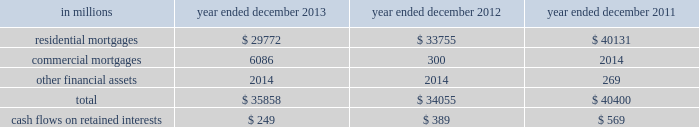Notes to consolidated financial statements note 10 .
Securitization activities the firm securitizes residential and commercial mortgages , corporate bonds , loans and other types of financial assets by selling these assets to securitization vehicles ( e.g. , trusts , corporate entities and limited liability companies ) or through a resecuritization .
The firm acts as underwriter of the beneficial interests that are sold to investors .
The firm 2019s residential mortgage securitizations are substantially all in connection with government agency securitizations .
Beneficial interests issued by securitization entities are debt or equity securities that give the investors rights to receive all or portions of specified cash inflows to a securitization vehicle and include senior and subordinated interests in principal , interest and/or other cash inflows .
The proceeds from the sale of beneficial interests are used to pay the transferor for the financial assets sold to the securitization vehicle or to purchase securities which serve as collateral .
The firm accounts for a securitization as a sale when it has relinquished control over the transferred assets .
Prior to securitization , the firm accounts for assets pending transfer at fair value and therefore does not typically recognize significant gains or losses upon the transfer of assets .
Net revenues from underwriting activities are recognized in connection with the sales of the underlying beneficial interests to investors .
For transfers of assets that are not accounted for as sales , the assets remain in 201cfinancial instruments owned , at fair value 201d and the transfer is accounted for as a collateralized financing , with the related interest expense recognized over the life of the transaction .
See notes 9 and 23 for further information about collateralized financings and interest expense , respectively .
The firm generally receives cash in exchange for the transferred assets but may also have continuing involvement with transferred assets , including ownership of beneficial interests in securitized financial assets , primarily in the form of senior or subordinated securities .
The firm may also purchase senior or subordinated securities issued by securitization vehicles ( which are typically vies ) in connection with secondary market-making activities .
The primary risks included in beneficial interests and other interests from the firm 2019s continuing involvement with securitization vehicles are the performance of the underlying collateral , the position of the firm 2019s investment in the capital structure of the securitization vehicle and the market yield for the security .
These interests are accounted for at fair value and are included in 201cfinancial instruments owned , at fair value 201d and are generally classified in level 2 of the fair value hierarchy .
See notes 5 through 8 for further information about fair value measurements .
The table below presents the amount of financial assets securitized and the cash flows received on retained interests in securitization entities in which the firm had continuing involvement. .
Goldman sachs 2013 annual report 165 .
In millions for 2013 , 2012 , and 2011 , what was total commercial mortgages? 
Computations: table_sum(commercial mortgages, none)
Answer: 8400.0. 